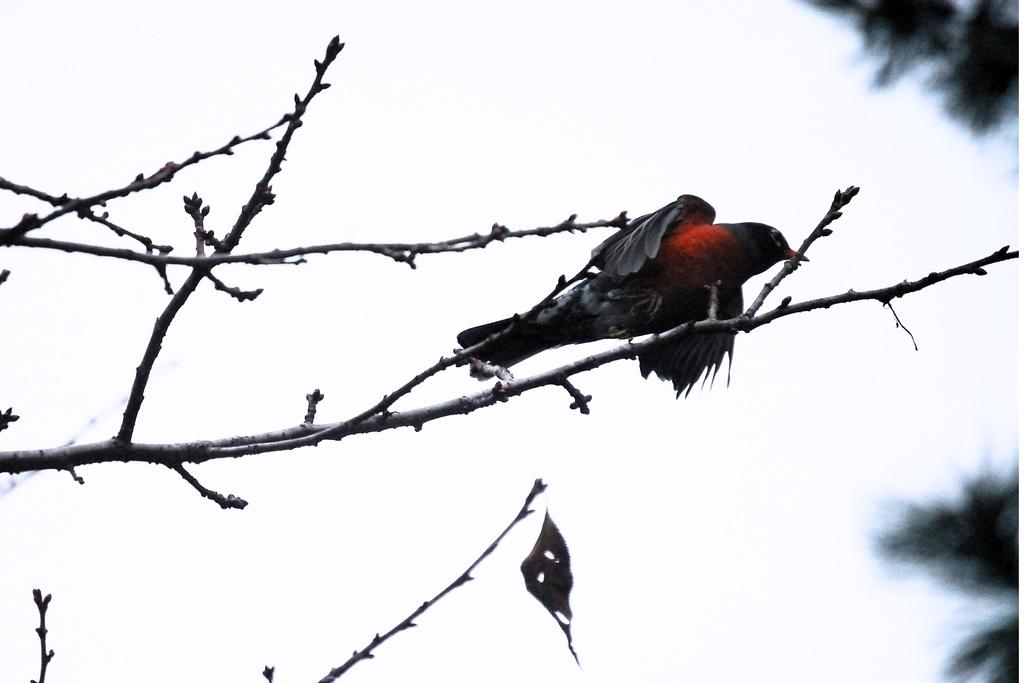What type of animal can be seen in the image? There is a bird in the image. Where is the bird located? The bird is on a tree branch. What can be seen on the right side of the image? There are trees on the right side of the image. What is visible in the background of the image? The sky is visible in the background of the image. What type of root can be seen growing near the bird in the image? There is no root visible in the image; the bird is on a tree branch. What is the bird's opinion on the current governor's policies in the image? The image does not provide any information about the bird's opinion on the current governor's policies. 